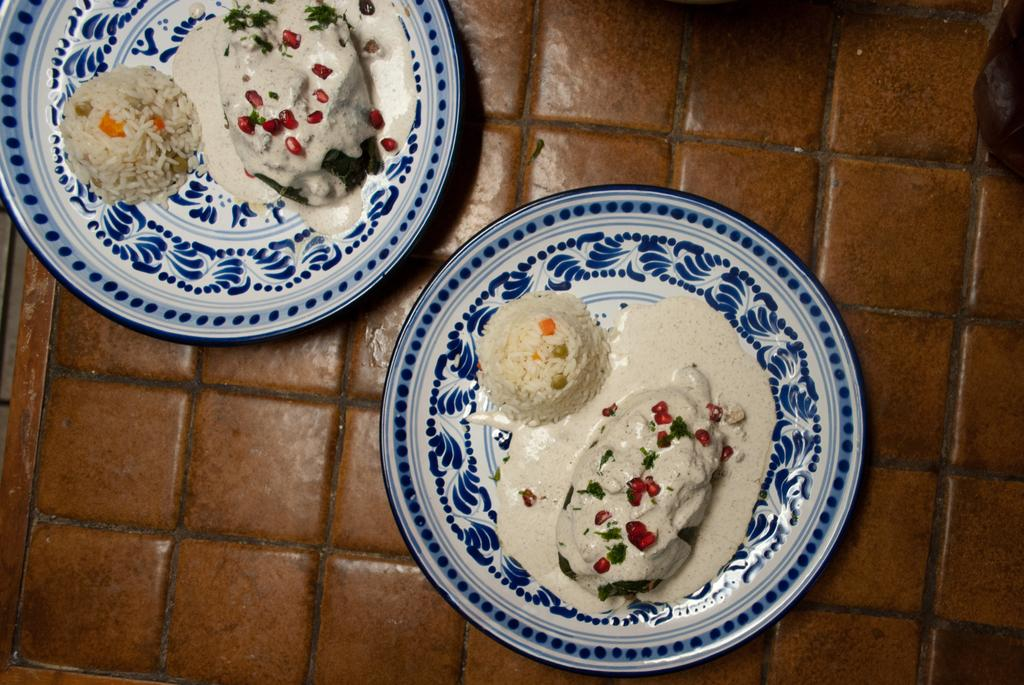What is on the floor in the image? There are two plates on the floor. What is on the plates? There is food on the plates. What can be observed about the appearance of the plates? The plates have a print or design on them. Who is the expert on the plates in the image? There is no expert present on the plates in the image. What is the cause of death for the person in the image? There is no person or indication of death in the image. 